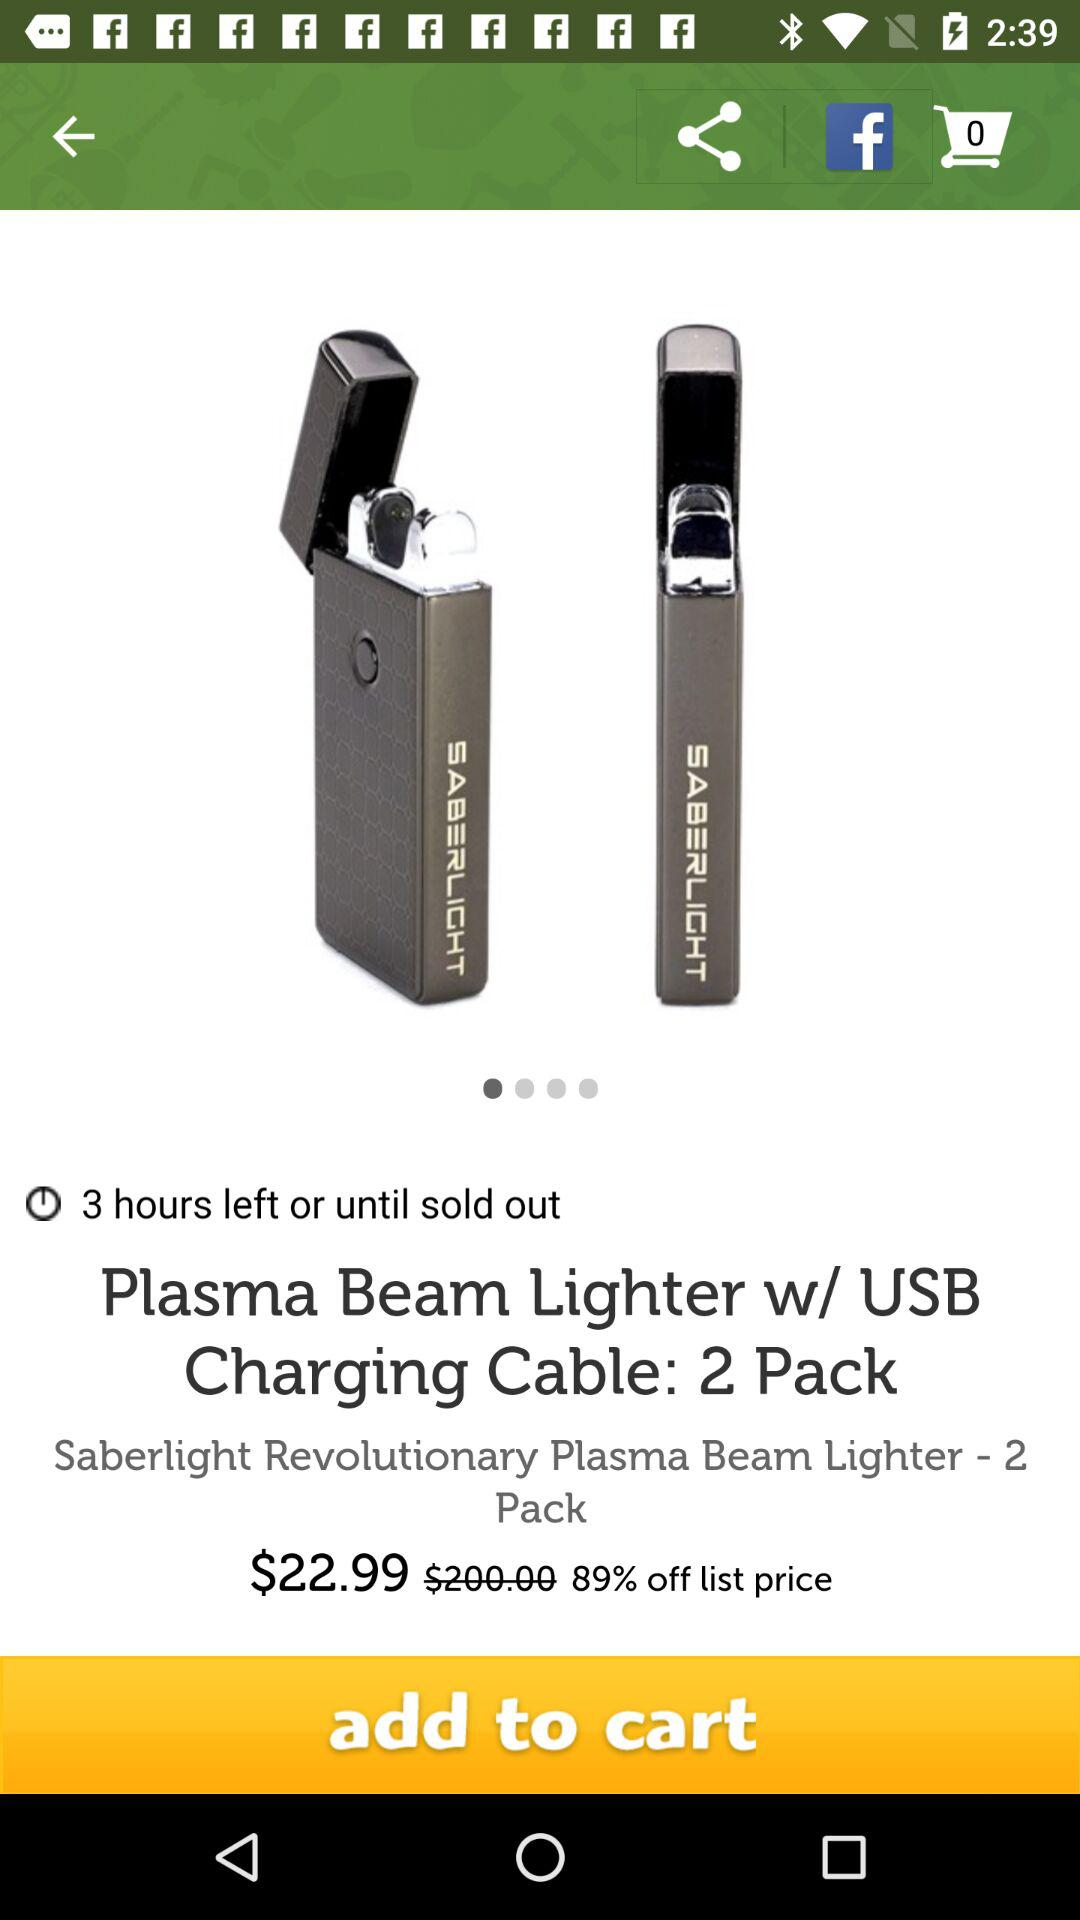How much is the discount on the lighter?
Answer the question using a single word or phrase. 89% 